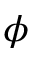<formula> <loc_0><loc_0><loc_500><loc_500>\phi</formula> 